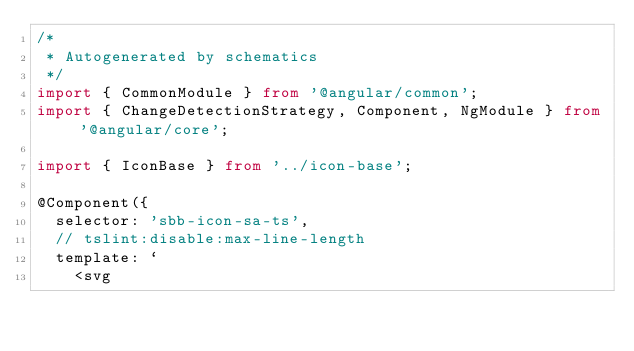Convert code to text. <code><loc_0><loc_0><loc_500><loc_500><_TypeScript_>/*
 * Autogenerated by schematics
 */
import { CommonModule } from '@angular/common';
import { ChangeDetectionStrategy, Component, NgModule } from '@angular/core';

import { IconBase } from '../icon-base';

@Component({
  selector: 'sbb-icon-sa-ts',
  // tslint:disable:max-line-length
  template: `
    <svg</code> 